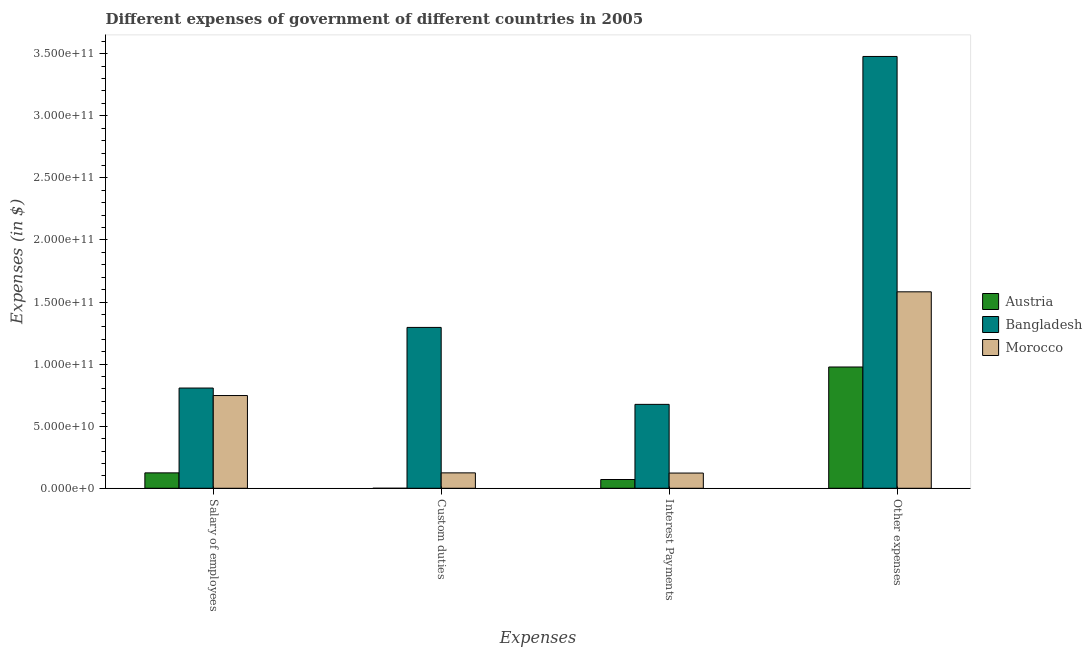How many bars are there on the 2nd tick from the left?
Ensure brevity in your answer.  3. What is the label of the 4th group of bars from the left?
Give a very brief answer. Other expenses. What is the amount spent on salary of employees in Austria?
Your answer should be very brief. 1.24e+1. Across all countries, what is the maximum amount spent on custom duties?
Your answer should be compact. 1.30e+11. Across all countries, what is the minimum amount spent on salary of employees?
Provide a short and direct response. 1.24e+1. In which country was the amount spent on salary of employees maximum?
Give a very brief answer. Bangladesh. What is the total amount spent on interest payments in the graph?
Ensure brevity in your answer.  8.69e+1. What is the difference between the amount spent on other expenses in Morocco and that in Austria?
Keep it short and to the point. 6.05e+1. What is the difference between the amount spent on interest payments in Bangladesh and the amount spent on other expenses in Austria?
Offer a terse response. -3.01e+1. What is the average amount spent on other expenses per country?
Offer a terse response. 2.01e+11. What is the difference between the amount spent on other expenses and amount spent on salary of employees in Bangladesh?
Provide a succinct answer. 2.67e+11. In how many countries, is the amount spent on salary of employees greater than 10000000000 $?
Your answer should be very brief. 3. What is the ratio of the amount spent on interest payments in Austria to that in Morocco?
Offer a very short reply. 0.58. What is the difference between the highest and the second highest amount spent on salary of employees?
Offer a terse response. 6.05e+09. What is the difference between the highest and the lowest amount spent on salary of employees?
Offer a terse response. 6.83e+1. What does the 3rd bar from the left in Other expenses represents?
Keep it short and to the point. Morocco. What does the 1st bar from the right in Custom duties represents?
Provide a short and direct response. Morocco. Is it the case that in every country, the sum of the amount spent on salary of employees and amount spent on custom duties is greater than the amount spent on interest payments?
Ensure brevity in your answer.  Yes. How many bars are there?
Give a very brief answer. 12. Are all the bars in the graph horizontal?
Your response must be concise. No. What is the difference between two consecutive major ticks on the Y-axis?
Your answer should be very brief. 5.00e+1. Are the values on the major ticks of Y-axis written in scientific E-notation?
Your answer should be very brief. Yes. Does the graph contain any zero values?
Provide a short and direct response. No. Does the graph contain grids?
Provide a succinct answer. No. Where does the legend appear in the graph?
Provide a short and direct response. Center right. How are the legend labels stacked?
Offer a very short reply. Vertical. What is the title of the graph?
Offer a terse response. Different expenses of government of different countries in 2005. What is the label or title of the X-axis?
Provide a short and direct response. Expenses. What is the label or title of the Y-axis?
Your answer should be very brief. Expenses (in $). What is the Expenses (in $) in Austria in Salary of employees?
Your answer should be compact. 1.24e+1. What is the Expenses (in $) in Bangladesh in Salary of employees?
Provide a succinct answer. 8.07e+1. What is the Expenses (in $) of Morocco in Salary of employees?
Offer a terse response. 7.47e+1. What is the Expenses (in $) in Austria in Custom duties?
Keep it short and to the point. 1.43e+06. What is the Expenses (in $) in Bangladesh in Custom duties?
Offer a terse response. 1.30e+11. What is the Expenses (in $) in Morocco in Custom duties?
Your answer should be compact. 1.24e+1. What is the Expenses (in $) in Austria in Interest Payments?
Ensure brevity in your answer.  7.06e+09. What is the Expenses (in $) in Bangladesh in Interest Payments?
Make the answer very short. 6.76e+1. What is the Expenses (in $) in Morocco in Interest Payments?
Your answer should be very brief. 1.23e+1. What is the Expenses (in $) in Austria in Other expenses?
Your answer should be very brief. 9.77e+1. What is the Expenses (in $) in Bangladesh in Other expenses?
Give a very brief answer. 3.48e+11. What is the Expenses (in $) of Morocco in Other expenses?
Your response must be concise. 1.58e+11. Across all Expenses, what is the maximum Expenses (in $) in Austria?
Your answer should be compact. 9.77e+1. Across all Expenses, what is the maximum Expenses (in $) of Bangladesh?
Your answer should be compact. 3.48e+11. Across all Expenses, what is the maximum Expenses (in $) in Morocco?
Offer a very short reply. 1.58e+11. Across all Expenses, what is the minimum Expenses (in $) of Austria?
Ensure brevity in your answer.  1.43e+06. Across all Expenses, what is the minimum Expenses (in $) in Bangladesh?
Offer a terse response. 6.76e+1. Across all Expenses, what is the minimum Expenses (in $) of Morocco?
Your response must be concise. 1.23e+1. What is the total Expenses (in $) of Austria in the graph?
Your answer should be very brief. 1.17e+11. What is the total Expenses (in $) in Bangladesh in the graph?
Give a very brief answer. 6.26e+11. What is the total Expenses (in $) of Morocco in the graph?
Offer a terse response. 2.58e+11. What is the difference between the Expenses (in $) in Austria in Salary of employees and that in Custom duties?
Give a very brief answer. 1.24e+1. What is the difference between the Expenses (in $) of Bangladesh in Salary of employees and that in Custom duties?
Give a very brief answer. -4.88e+1. What is the difference between the Expenses (in $) of Morocco in Salary of employees and that in Custom duties?
Give a very brief answer. 6.23e+1. What is the difference between the Expenses (in $) of Austria in Salary of employees and that in Interest Payments?
Offer a very short reply. 5.34e+09. What is the difference between the Expenses (in $) of Bangladesh in Salary of employees and that in Interest Payments?
Your answer should be compact. 1.32e+1. What is the difference between the Expenses (in $) in Morocco in Salary of employees and that in Interest Payments?
Offer a terse response. 6.24e+1. What is the difference between the Expenses (in $) in Austria in Salary of employees and that in Other expenses?
Give a very brief answer. -8.53e+1. What is the difference between the Expenses (in $) of Bangladesh in Salary of employees and that in Other expenses?
Provide a succinct answer. -2.67e+11. What is the difference between the Expenses (in $) in Morocco in Salary of employees and that in Other expenses?
Your answer should be compact. -8.35e+1. What is the difference between the Expenses (in $) in Austria in Custom duties and that in Interest Payments?
Provide a succinct answer. -7.06e+09. What is the difference between the Expenses (in $) in Bangladesh in Custom duties and that in Interest Payments?
Offer a very short reply. 6.20e+1. What is the difference between the Expenses (in $) in Morocco in Custom duties and that in Interest Payments?
Offer a terse response. 1.45e+08. What is the difference between the Expenses (in $) in Austria in Custom duties and that in Other expenses?
Keep it short and to the point. -9.77e+1. What is the difference between the Expenses (in $) in Bangladesh in Custom duties and that in Other expenses?
Ensure brevity in your answer.  -2.18e+11. What is the difference between the Expenses (in $) in Morocco in Custom duties and that in Other expenses?
Provide a short and direct response. -1.46e+11. What is the difference between the Expenses (in $) in Austria in Interest Payments and that in Other expenses?
Your answer should be very brief. -9.06e+1. What is the difference between the Expenses (in $) of Bangladesh in Interest Payments and that in Other expenses?
Provide a short and direct response. -2.80e+11. What is the difference between the Expenses (in $) of Morocco in Interest Payments and that in Other expenses?
Ensure brevity in your answer.  -1.46e+11. What is the difference between the Expenses (in $) in Austria in Salary of employees and the Expenses (in $) in Bangladesh in Custom duties?
Offer a terse response. -1.17e+11. What is the difference between the Expenses (in $) in Austria in Salary of employees and the Expenses (in $) in Morocco in Custom duties?
Offer a very short reply. -1.45e+06. What is the difference between the Expenses (in $) of Bangladesh in Salary of employees and the Expenses (in $) of Morocco in Custom duties?
Give a very brief answer. 6.83e+1. What is the difference between the Expenses (in $) of Austria in Salary of employees and the Expenses (in $) of Bangladesh in Interest Payments?
Keep it short and to the point. -5.52e+1. What is the difference between the Expenses (in $) in Austria in Salary of employees and the Expenses (in $) in Morocco in Interest Payments?
Provide a succinct answer. 1.43e+08. What is the difference between the Expenses (in $) of Bangladesh in Salary of employees and the Expenses (in $) of Morocco in Interest Payments?
Make the answer very short. 6.85e+1. What is the difference between the Expenses (in $) of Austria in Salary of employees and the Expenses (in $) of Bangladesh in Other expenses?
Provide a short and direct response. -3.35e+11. What is the difference between the Expenses (in $) in Austria in Salary of employees and the Expenses (in $) in Morocco in Other expenses?
Provide a short and direct response. -1.46e+11. What is the difference between the Expenses (in $) of Bangladesh in Salary of employees and the Expenses (in $) of Morocco in Other expenses?
Offer a very short reply. -7.75e+1. What is the difference between the Expenses (in $) of Austria in Custom duties and the Expenses (in $) of Bangladesh in Interest Payments?
Keep it short and to the point. -6.76e+1. What is the difference between the Expenses (in $) in Austria in Custom duties and the Expenses (in $) in Morocco in Interest Payments?
Provide a short and direct response. -1.23e+1. What is the difference between the Expenses (in $) in Bangladesh in Custom duties and the Expenses (in $) in Morocco in Interest Payments?
Your answer should be very brief. 1.17e+11. What is the difference between the Expenses (in $) in Austria in Custom duties and the Expenses (in $) in Bangladesh in Other expenses?
Provide a succinct answer. -3.48e+11. What is the difference between the Expenses (in $) in Austria in Custom duties and the Expenses (in $) in Morocco in Other expenses?
Offer a very short reply. -1.58e+11. What is the difference between the Expenses (in $) in Bangladesh in Custom duties and the Expenses (in $) in Morocco in Other expenses?
Provide a succinct answer. -2.87e+1. What is the difference between the Expenses (in $) in Austria in Interest Payments and the Expenses (in $) in Bangladesh in Other expenses?
Provide a succinct answer. -3.41e+11. What is the difference between the Expenses (in $) in Austria in Interest Payments and the Expenses (in $) in Morocco in Other expenses?
Keep it short and to the point. -1.51e+11. What is the difference between the Expenses (in $) of Bangladesh in Interest Payments and the Expenses (in $) of Morocco in Other expenses?
Give a very brief answer. -9.06e+1. What is the average Expenses (in $) in Austria per Expenses?
Offer a terse response. 2.93e+1. What is the average Expenses (in $) of Bangladesh per Expenses?
Your answer should be very brief. 1.56e+11. What is the average Expenses (in $) in Morocco per Expenses?
Provide a succinct answer. 6.44e+1. What is the difference between the Expenses (in $) in Austria and Expenses (in $) in Bangladesh in Salary of employees?
Offer a very short reply. -6.83e+1. What is the difference between the Expenses (in $) of Austria and Expenses (in $) of Morocco in Salary of employees?
Offer a very short reply. -6.23e+1. What is the difference between the Expenses (in $) of Bangladesh and Expenses (in $) of Morocco in Salary of employees?
Provide a succinct answer. 6.05e+09. What is the difference between the Expenses (in $) in Austria and Expenses (in $) in Bangladesh in Custom duties?
Your answer should be very brief. -1.30e+11. What is the difference between the Expenses (in $) of Austria and Expenses (in $) of Morocco in Custom duties?
Keep it short and to the point. -1.24e+1. What is the difference between the Expenses (in $) of Bangladesh and Expenses (in $) of Morocco in Custom duties?
Offer a terse response. 1.17e+11. What is the difference between the Expenses (in $) of Austria and Expenses (in $) of Bangladesh in Interest Payments?
Ensure brevity in your answer.  -6.05e+1. What is the difference between the Expenses (in $) of Austria and Expenses (in $) of Morocco in Interest Payments?
Your answer should be very brief. -5.20e+09. What is the difference between the Expenses (in $) in Bangladesh and Expenses (in $) in Morocco in Interest Payments?
Provide a succinct answer. 5.53e+1. What is the difference between the Expenses (in $) in Austria and Expenses (in $) in Bangladesh in Other expenses?
Provide a succinct answer. -2.50e+11. What is the difference between the Expenses (in $) in Austria and Expenses (in $) in Morocco in Other expenses?
Make the answer very short. -6.05e+1. What is the difference between the Expenses (in $) in Bangladesh and Expenses (in $) in Morocco in Other expenses?
Keep it short and to the point. 1.90e+11. What is the ratio of the Expenses (in $) in Austria in Salary of employees to that in Custom duties?
Ensure brevity in your answer.  8676.61. What is the ratio of the Expenses (in $) of Bangladesh in Salary of employees to that in Custom duties?
Ensure brevity in your answer.  0.62. What is the ratio of the Expenses (in $) of Morocco in Salary of employees to that in Custom duties?
Offer a terse response. 6.02. What is the ratio of the Expenses (in $) in Austria in Salary of employees to that in Interest Payments?
Your response must be concise. 1.76. What is the ratio of the Expenses (in $) of Bangladesh in Salary of employees to that in Interest Payments?
Make the answer very short. 1.19. What is the ratio of the Expenses (in $) of Morocco in Salary of employees to that in Interest Payments?
Keep it short and to the point. 6.09. What is the ratio of the Expenses (in $) of Austria in Salary of employees to that in Other expenses?
Offer a very short reply. 0.13. What is the ratio of the Expenses (in $) of Bangladesh in Salary of employees to that in Other expenses?
Your response must be concise. 0.23. What is the ratio of the Expenses (in $) of Morocco in Salary of employees to that in Other expenses?
Offer a very short reply. 0.47. What is the ratio of the Expenses (in $) of Bangladesh in Custom duties to that in Interest Payments?
Offer a very short reply. 1.92. What is the ratio of the Expenses (in $) of Morocco in Custom duties to that in Interest Payments?
Provide a succinct answer. 1.01. What is the ratio of the Expenses (in $) in Austria in Custom duties to that in Other expenses?
Provide a short and direct response. 0. What is the ratio of the Expenses (in $) in Bangladesh in Custom duties to that in Other expenses?
Offer a terse response. 0.37. What is the ratio of the Expenses (in $) in Morocco in Custom duties to that in Other expenses?
Ensure brevity in your answer.  0.08. What is the ratio of the Expenses (in $) in Austria in Interest Payments to that in Other expenses?
Keep it short and to the point. 0.07. What is the ratio of the Expenses (in $) in Bangladesh in Interest Payments to that in Other expenses?
Ensure brevity in your answer.  0.19. What is the ratio of the Expenses (in $) of Morocco in Interest Payments to that in Other expenses?
Provide a short and direct response. 0.08. What is the difference between the highest and the second highest Expenses (in $) in Austria?
Your answer should be very brief. 8.53e+1. What is the difference between the highest and the second highest Expenses (in $) of Bangladesh?
Your response must be concise. 2.18e+11. What is the difference between the highest and the second highest Expenses (in $) in Morocco?
Offer a terse response. 8.35e+1. What is the difference between the highest and the lowest Expenses (in $) in Austria?
Offer a terse response. 9.77e+1. What is the difference between the highest and the lowest Expenses (in $) of Bangladesh?
Your answer should be compact. 2.80e+11. What is the difference between the highest and the lowest Expenses (in $) of Morocco?
Offer a terse response. 1.46e+11. 